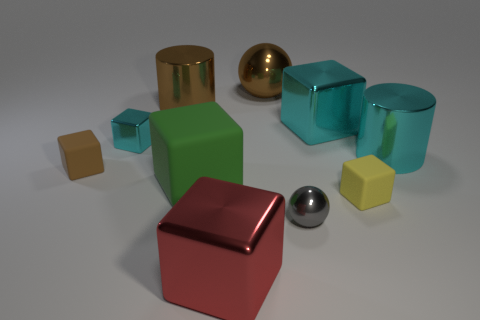Subtract all small brown blocks. How many blocks are left? 5 Subtract 1 spheres. How many spheres are left? 1 Subtract all yellow cubes. How many cubes are left? 5 Subtract all cubes. How many objects are left? 4 Subtract all gray balls. Subtract all cyan cylinders. How many balls are left? 1 Subtract all blue cubes. How many yellow cylinders are left? 0 Subtract all small blue objects. Subtract all big red shiny things. How many objects are left? 9 Add 9 large brown metallic cylinders. How many large brown metallic cylinders are left? 10 Add 3 small blue matte cubes. How many small blue matte cubes exist? 3 Subtract 0 yellow spheres. How many objects are left? 10 